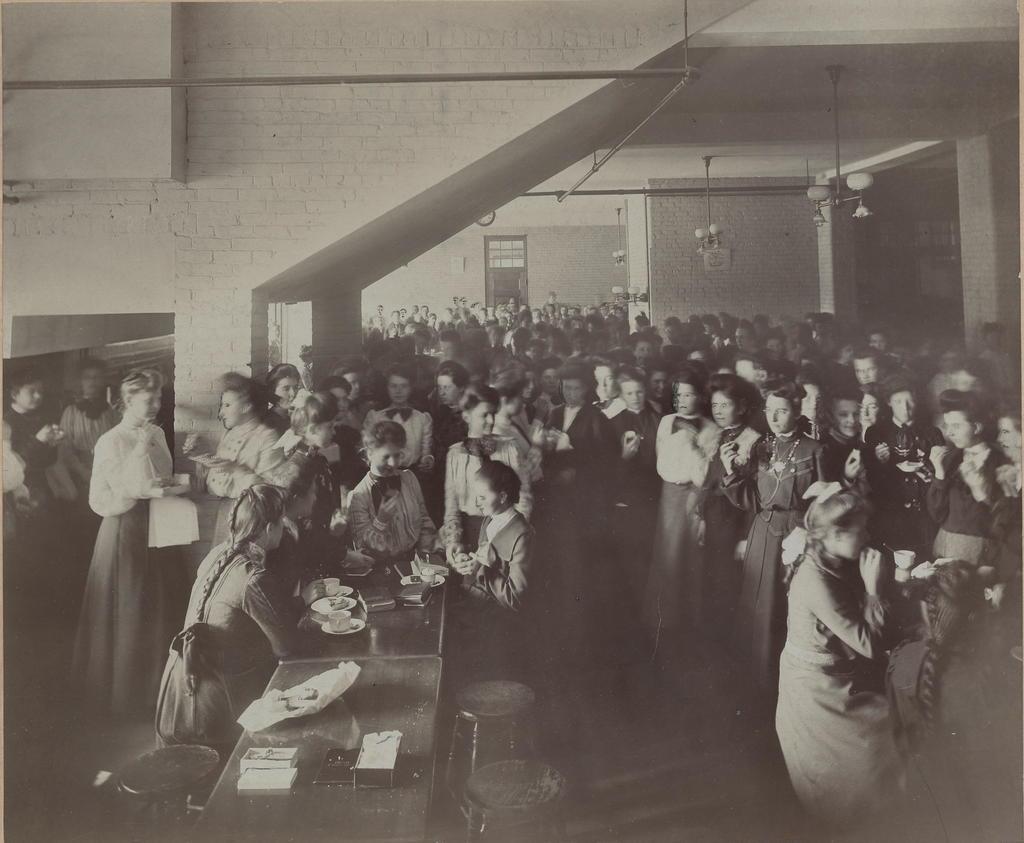In one or two sentences, can you explain what this image depicts? In this image we can see the people standing. We can also see the table, stools and on the table we can see the papers, plates, cups and also some other objects. We can also see the wall, pillars, windows and also the lights hanged from the ceiling. 